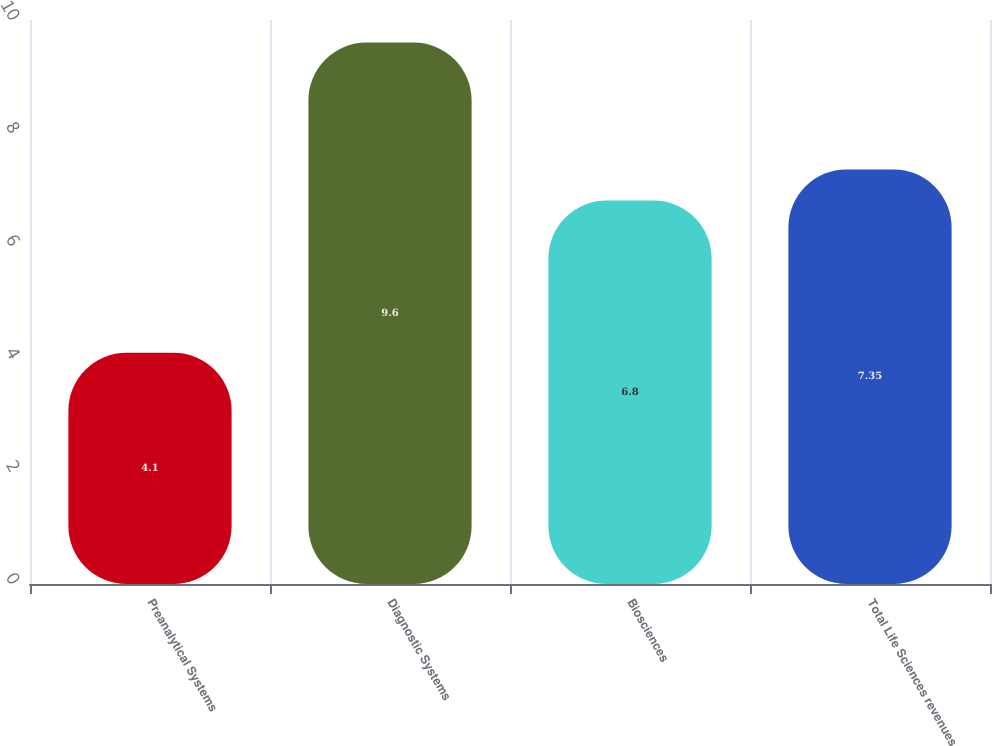Convert chart to OTSL. <chart><loc_0><loc_0><loc_500><loc_500><bar_chart><fcel>Preanalytical Systems<fcel>Diagnostic Systems<fcel>Biosciences<fcel>Total Life Sciences revenues<nl><fcel>4.1<fcel>9.6<fcel>6.8<fcel>7.35<nl></chart> 